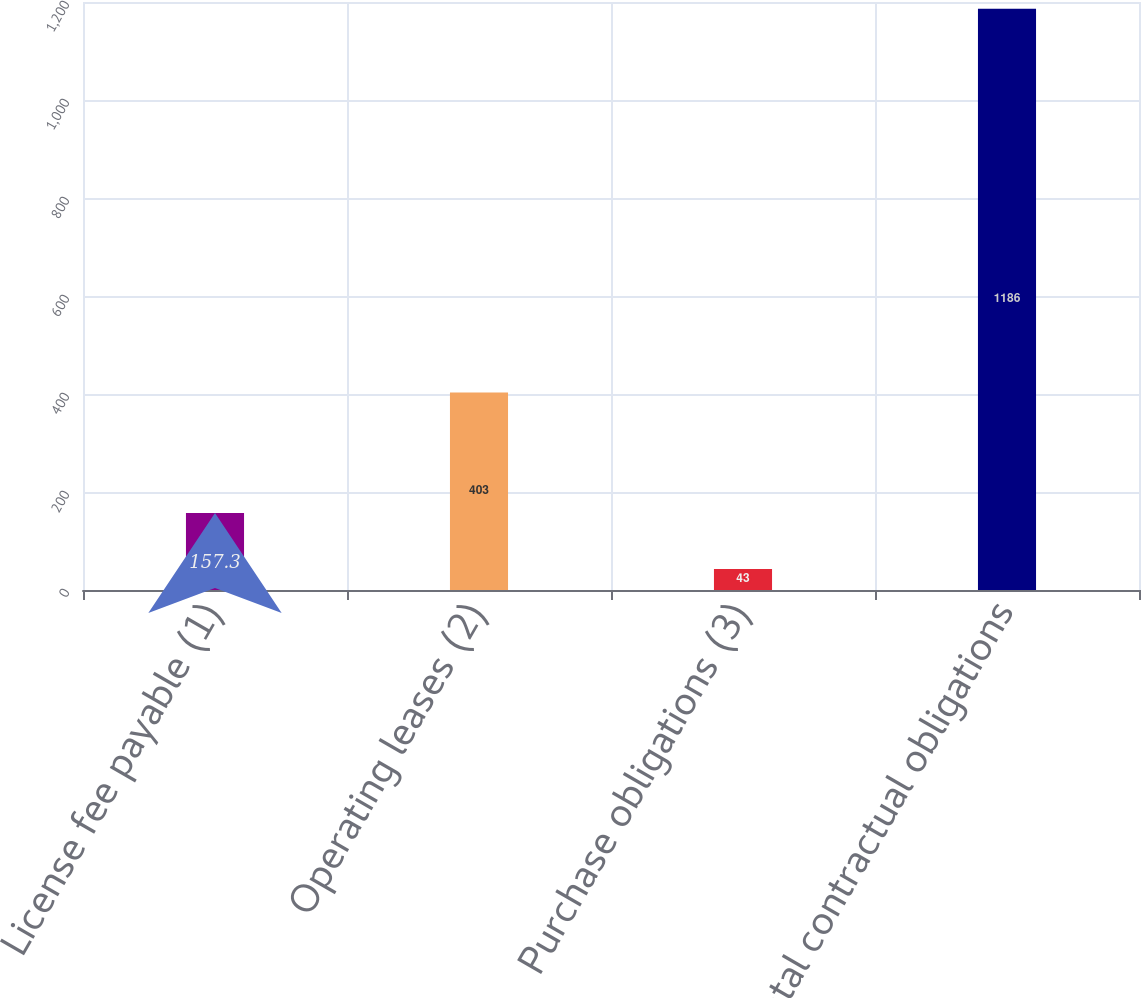Convert chart to OTSL. <chart><loc_0><loc_0><loc_500><loc_500><bar_chart><fcel>License fee payable (1)<fcel>Operating leases (2)<fcel>Purchase obligations (3)<fcel>Total contractual obligations<nl><fcel>157.3<fcel>403<fcel>43<fcel>1186<nl></chart> 